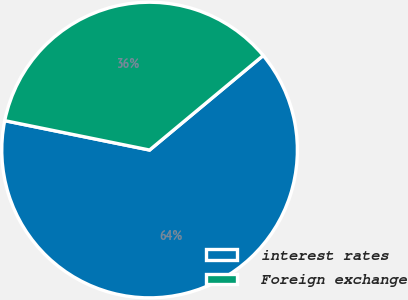<chart> <loc_0><loc_0><loc_500><loc_500><pie_chart><fcel>interest rates<fcel>Foreign exchange<nl><fcel>64.23%<fcel>35.77%<nl></chart> 